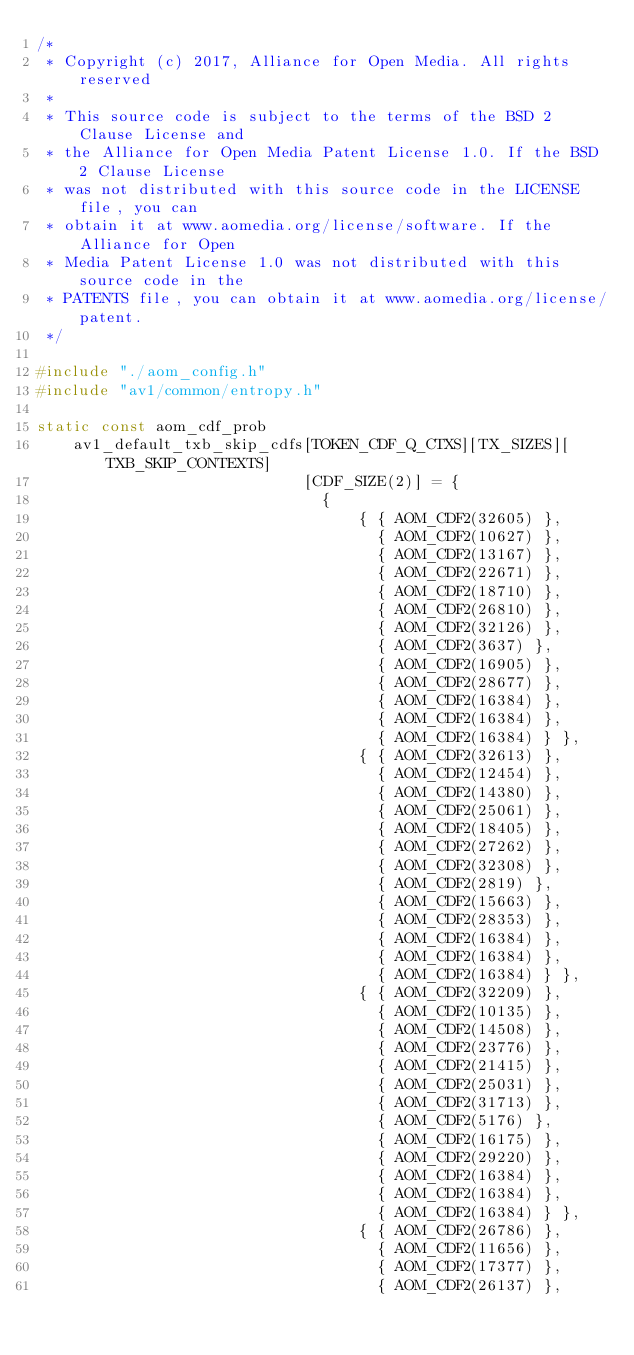<code> <loc_0><loc_0><loc_500><loc_500><_C_>/*
 * Copyright (c) 2017, Alliance for Open Media. All rights reserved
 *
 * This source code is subject to the terms of the BSD 2 Clause License and
 * the Alliance for Open Media Patent License 1.0. If the BSD 2 Clause License
 * was not distributed with this source code in the LICENSE file, you can
 * obtain it at www.aomedia.org/license/software. If the Alliance for Open
 * Media Patent License 1.0 was not distributed with this source code in the
 * PATENTS file, you can obtain it at www.aomedia.org/license/patent.
 */

#include "./aom_config.h"
#include "av1/common/entropy.h"

static const aom_cdf_prob
    av1_default_txb_skip_cdfs[TOKEN_CDF_Q_CTXS][TX_SIZES][TXB_SKIP_CONTEXTS]
                             [CDF_SIZE(2)] = {
                               {
                                   { { AOM_CDF2(32605) },
                                     { AOM_CDF2(10627) },
                                     { AOM_CDF2(13167) },
                                     { AOM_CDF2(22671) },
                                     { AOM_CDF2(18710) },
                                     { AOM_CDF2(26810) },
                                     { AOM_CDF2(32126) },
                                     { AOM_CDF2(3637) },
                                     { AOM_CDF2(16905) },
                                     { AOM_CDF2(28677) },
                                     { AOM_CDF2(16384) },
                                     { AOM_CDF2(16384) },
                                     { AOM_CDF2(16384) } },
                                   { { AOM_CDF2(32613) },
                                     { AOM_CDF2(12454) },
                                     { AOM_CDF2(14380) },
                                     { AOM_CDF2(25061) },
                                     { AOM_CDF2(18405) },
                                     { AOM_CDF2(27262) },
                                     { AOM_CDF2(32308) },
                                     { AOM_CDF2(2819) },
                                     { AOM_CDF2(15663) },
                                     { AOM_CDF2(28353) },
                                     { AOM_CDF2(16384) },
                                     { AOM_CDF2(16384) },
                                     { AOM_CDF2(16384) } },
                                   { { AOM_CDF2(32209) },
                                     { AOM_CDF2(10135) },
                                     { AOM_CDF2(14508) },
                                     { AOM_CDF2(23776) },
                                     { AOM_CDF2(21415) },
                                     { AOM_CDF2(25031) },
                                     { AOM_CDF2(31713) },
                                     { AOM_CDF2(5176) },
                                     { AOM_CDF2(16175) },
                                     { AOM_CDF2(29220) },
                                     { AOM_CDF2(16384) },
                                     { AOM_CDF2(16384) },
                                     { AOM_CDF2(16384) } },
                                   { { AOM_CDF2(26786) },
                                     { AOM_CDF2(11656) },
                                     { AOM_CDF2(17377) },
                                     { AOM_CDF2(26137) },</code> 